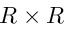<formula> <loc_0><loc_0><loc_500><loc_500>R \times R</formula> 